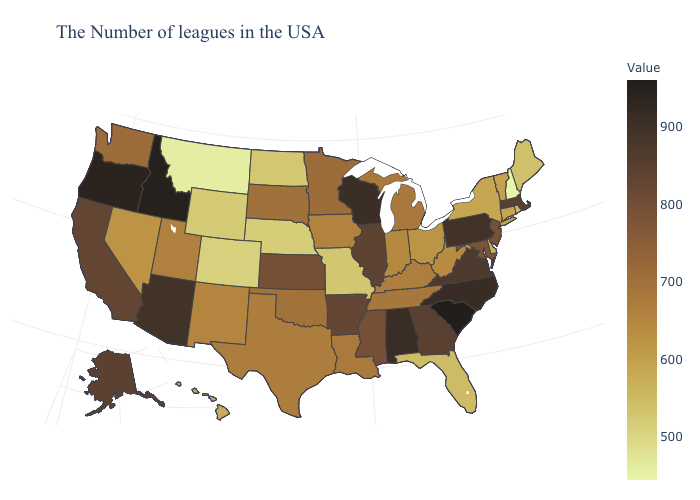Does New Hampshire have the lowest value in the USA?
Give a very brief answer. Yes. Does New Mexico have a higher value than Arizona?
Keep it brief. No. Which states have the highest value in the USA?
Quick response, please. South Carolina. Among the states that border Texas , which have the lowest value?
Write a very short answer. New Mexico. Which states hav the highest value in the South?
Write a very short answer. South Carolina. Among the states that border New York , does Pennsylvania have the highest value?
Short answer required. Yes. 